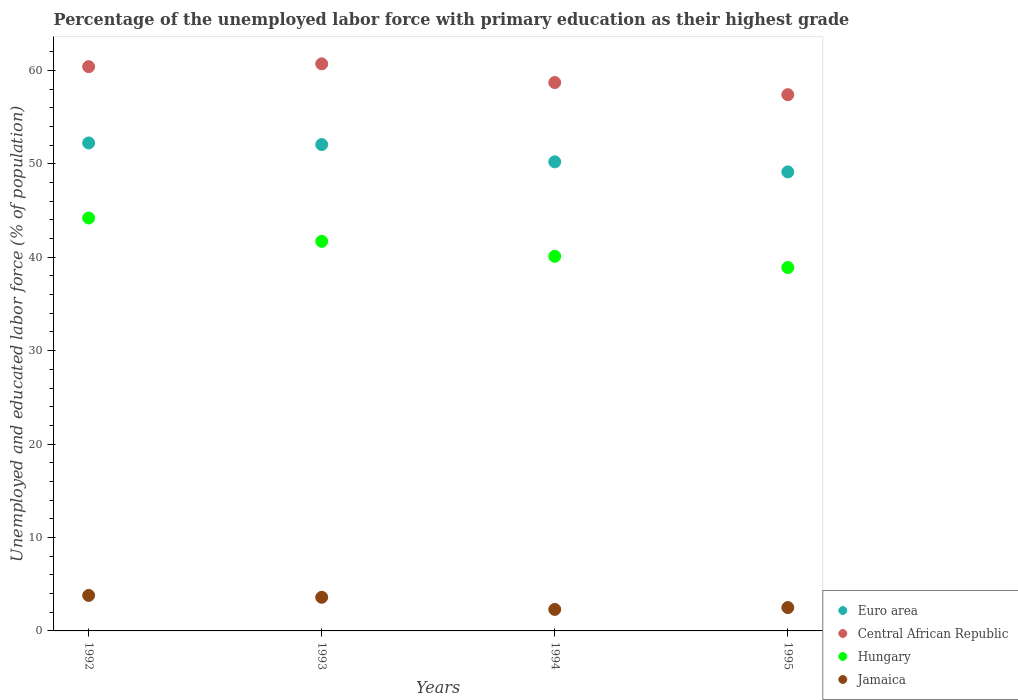What is the percentage of the unemployed labor force with primary education in Jamaica in 1994?
Give a very brief answer. 2.3. Across all years, what is the maximum percentage of the unemployed labor force with primary education in Euro area?
Provide a short and direct response. 52.23. Across all years, what is the minimum percentage of the unemployed labor force with primary education in Jamaica?
Make the answer very short. 2.3. What is the total percentage of the unemployed labor force with primary education in Jamaica in the graph?
Ensure brevity in your answer.  12.2. What is the difference between the percentage of the unemployed labor force with primary education in Hungary in 1992 and that in 1993?
Make the answer very short. 2.5. What is the difference between the percentage of the unemployed labor force with primary education in Hungary in 1993 and the percentage of the unemployed labor force with primary education in Euro area in 1995?
Ensure brevity in your answer.  -7.43. What is the average percentage of the unemployed labor force with primary education in Jamaica per year?
Keep it short and to the point. 3.05. In the year 1995, what is the difference between the percentage of the unemployed labor force with primary education in Euro area and percentage of the unemployed labor force with primary education in Central African Republic?
Give a very brief answer. -8.27. In how many years, is the percentage of the unemployed labor force with primary education in Hungary greater than 46 %?
Your answer should be compact. 0. What is the ratio of the percentage of the unemployed labor force with primary education in Euro area in 1992 to that in 1994?
Your answer should be very brief. 1.04. Is the percentage of the unemployed labor force with primary education in Jamaica in 1994 less than that in 1995?
Your answer should be very brief. Yes. Is the difference between the percentage of the unemployed labor force with primary education in Euro area in 1994 and 1995 greater than the difference between the percentage of the unemployed labor force with primary education in Central African Republic in 1994 and 1995?
Keep it short and to the point. No. What is the difference between the highest and the lowest percentage of the unemployed labor force with primary education in Euro area?
Offer a terse response. 3.1. In how many years, is the percentage of the unemployed labor force with primary education in Euro area greater than the average percentage of the unemployed labor force with primary education in Euro area taken over all years?
Your answer should be very brief. 2. Is it the case that in every year, the sum of the percentage of the unemployed labor force with primary education in Jamaica and percentage of the unemployed labor force with primary education in Euro area  is greater than the percentage of the unemployed labor force with primary education in Central African Republic?
Your answer should be compact. No. Does the percentage of the unemployed labor force with primary education in Hungary monotonically increase over the years?
Make the answer very short. No. How many dotlines are there?
Your answer should be very brief. 4. How many years are there in the graph?
Your response must be concise. 4. Are the values on the major ticks of Y-axis written in scientific E-notation?
Give a very brief answer. No. Does the graph contain any zero values?
Keep it short and to the point. No. How are the legend labels stacked?
Offer a terse response. Vertical. What is the title of the graph?
Your response must be concise. Percentage of the unemployed labor force with primary education as their highest grade. Does "Uruguay" appear as one of the legend labels in the graph?
Provide a succinct answer. No. What is the label or title of the X-axis?
Ensure brevity in your answer.  Years. What is the label or title of the Y-axis?
Offer a very short reply. Unemployed and educated labor force (% of population). What is the Unemployed and educated labor force (% of population) in Euro area in 1992?
Keep it short and to the point. 52.23. What is the Unemployed and educated labor force (% of population) in Central African Republic in 1992?
Keep it short and to the point. 60.4. What is the Unemployed and educated labor force (% of population) of Hungary in 1992?
Ensure brevity in your answer.  44.2. What is the Unemployed and educated labor force (% of population) of Jamaica in 1992?
Your answer should be very brief. 3.8. What is the Unemployed and educated labor force (% of population) of Euro area in 1993?
Provide a succinct answer. 52.06. What is the Unemployed and educated labor force (% of population) of Central African Republic in 1993?
Your response must be concise. 60.7. What is the Unemployed and educated labor force (% of population) of Hungary in 1993?
Offer a terse response. 41.7. What is the Unemployed and educated labor force (% of population) of Jamaica in 1993?
Your answer should be compact. 3.6. What is the Unemployed and educated labor force (% of population) in Euro area in 1994?
Ensure brevity in your answer.  50.21. What is the Unemployed and educated labor force (% of population) in Central African Republic in 1994?
Give a very brief answer. 58.7. What is the Unemployed and educated labor force (% of population) of Hungary in 1994?
Provide a short and direct response. 40.1. What is the Unemployed and educated labor force (% of population) in Jamaica in 1994?
Ensure brevity in your answer.  2.3. What is the Unemployed and educated labor force (% of population) of Euro area in 1995?
Offer a terse response. 49.13. What is the Unemployed and educated labor force (% of population) of Central African Republic in 1995?
Provide a succinct answer. 57.4. What is the Unemployed and educated labor force (% of population) in Hungary in 1995?
Keep it short and to the point. 38.9. What is the Unemployed and educated labor force (% of population) in Jamaica in 1995?
Give a very brief answer. 2.5. Across all years, what is the maximum Unemployed and educated labor force (% of population) of Euro area?
Ensure brevity in your answer.  52.23. Across all years, what is the maximum Unemployed and educated labor force (% of population) in Central African Republic?
Keep it short and to the point. 60.7. Across all years, what is the maximum Unemployed and educated labor force (% of population) of Hungary?
Provide a succinct answer. 44.2. Across all years, what is the maximum Unemployed and educated labor force (% of population) in Jamaica?
Offer a very short reply. 3.8. Across all years, what is the minimum Unemployed and educated labor force (% of population) of Euro area?
Offer a very short reply. 49.13. Across all years, what is the minimum Unemployed and educated labor force (% of population) of Central African Republic?
Offer a terse response. 57.4. Across all years, what is the minimum Unemployed and educated labor force (% of population) of Hungary?
Ensure brevity in your answer.  38.9. Across all years, what is the minimum Unemployed and educated labor force (% of population) of Jamaica?
Keep it short and to the point. 2.3. What is the total Unemployed and educated labor force (% of population) of Euro area in the graph?
Offer a very short reply. 203.64. What is the total Unemployed and educated labor force (% of population) of Central African Republic in the graph?
Your answer should be very brief. 237.2. What is the total Unemployed and educated labor force (% of population) of Hungary in the graph?
Keep it short and to the point. 164.9. What is the total Unemployed and educated labor force (% of population) of Jamaica in the graph?
Your answer should be very brief. 12.2. What is the difference between the Unemployed and educated labor force (% of population) of Euro area in 1992 and that in 1993?
Provide a short and direct response. 0.17. What is the difference between the Unemployed and educated labor force (% of population) of Central African Republic in 1992 and that in 1993?
Your response must be concise. -0.3. What is the difference between the Unemployed and educated labor force (% of population) of Jamaica in 1992 and that in 1993?
Make the answer very short. 0.2. What is the difference between the Unemployed and educated labor force (% of population) in Euro area in 1992 and that in 1994?
Provide a short and direct response. 2.02. What is the difference between the Unemployed and educated labor force (% of population) in Central African Republic in 1992 and that in 1994?
Your answer should be very brief. 1.7. What is the difference between the Unemployed and educated labor force (% of population) in Jamaica in 1992 and that in 1994?
Offer a terse response. 1.5. What is the difference between the Unemployed and educated labor force (% of population) in Euro area in 1992 and that in 1995?
Your answer should be compact. 3.1. What is the difference between the Unemployed and educated labor force (% of population) in Central African Republic in 1992 and that in 1995?
Your answer should be very brief. 3. What is the difference between the Unemployed and educated labor force (% of population) of Hungary in 1992 and that in 1995?
Provide a succinct answer. 5.3. What is the difference between the Unemployed and educated labor force (% of population) of Euro area in 1993 and that in 1994?
Your answer should be very brief. 1.85. What is the difference between the Unemployed and educated labor force (% of population) of Jamaica in 1993 and that in 1994?
Your response must be concise. 1.3. What is the difference between the Unemployed and educated labor force (% of population) of Euro area in 1993 and that in 1995?
Ensure brevity in your answer.  2.93. What is the difference between the Unemployed and educated labor force (% of population) of Hungary in 1993 and that in 1995?
Offer a very short reply. 2.8. What is the difference between the Unemployed and educated labor force (% of population) of Jamaica in 1993 and that in 1995?
Offer a terse response. 1.1. What is the difference between the Unemployed and educated labor force (% of population) of Euro area in 1994 and that in 1995?
Give a very brief answer. 1.08. What is the difference between the Unemployed and educated labor force (% of population) in Hungary in 1994 and that in 1995?
Give a very brief answer. 1.2. What is the difference between the Unemployed and educated labor force (% of population) of Euro area in 1992 and the Unemployed and educated labor force (% of population) of Central African Republic in 1993?
Your response must be concise. -8.47. What is the difference between the Unemployed and educated labor force (% of population) of Euro area in 1992 and the Unemployed and educated labor force (% of population) of Hungary in 1993?
Ensure brevity in your answer.  10.53. What is the difference between the Unemployed and educated labor force (% of population) of Euro area in 1992 and the Unemployed and educated labor force (% of population) of Jamaica in 1993?
Ensure brevity in your answer.  48.63. What is the difference between the Unemployed and educated labor force (% of population) of Central African Republic in 1992 and the Unemployed and educated labor force (% of population) of Hungary in 1993?
Keep it short and to the point. 18.7. What is the difference between the Unemployed and educated labor force (% of population) of Central African Republic in 1992 and the Unemployed and educated labor force (% of population) of Jamaica in 1993?
Provide a succinct answer. 56.8. What is the difference between the Unemployed and educated labor force (% of population) of Hungary in 1992 and the Unemployed and educated labor force (% of population) of Jamaica in 1993?
Your answer should be very brief. 40.6. What is the difference between the Unemployed and educated labor force (% of population) of Euro area in 1992 and the Unemployed and educated labor force (% of population) of Central African Republic in 1994?
Offer a terse response. -6.47. What is the difference between the Unemployed and educated labor force (% of population) in Euro area in 1992 and the Unemployed and educated labor force (% of population) in Hungary in 1994?
Offer a very short reply. 12.13. What is the difference between the Unemployed and educated labor force (% of population) of Euro area in 1992 and the Unemployed and educated labor force (% of population) of Jamaica in 1994?
Your response must be concise. 49.93. What is the difference between the Unemployed and educated labor force (% of population) of Central African Republic in 1992 and the Unemployed and educated labor force (% of population) of Hungary in 1994?
Ensure brevity in your answer.  20.3. What is the difference between the Unemployed and educated labor force (% of population) of Central African Republic in 1992 and the Unemployed and educated labor force (% of population) of Jamaica in 1994?
Make the answer very short. 58.1. What is the difference between the Unemployed and educated labor force (% of population) in Hungary in 1992 and the Unemployed and educated labor force (% of population) in Jamaica in 1994?
Provide a succinct answer. 41.9. What is the difference between the Unemployed and educated labor force (% of population) in Euro area in 1992 and the Unemployed and educated labor force (% of population) in Central African Republic in 1995?
Your response must be concise. -5.17. What is the difference between the Unemployed and educated labor force (% of population) of Euro area in 1992 and the Unemployed and educated labor force (% of population) of Hungary in 1995?
Give a very brief answer. 13.33. What is the difference between the Unemployed and educated labor force (% of population) of Euro area in 1992 and the Unemployed and educated labor force (% of population) of Jamaica in 1995?
Provide a succinct answer. 49.73. What is the difference between the Unemployed and educated labor force (% of population) in Central African Republic in 1992 and the Unemployed and educated labor force (% of population) in Jamaica in 1995?
Offer a very short reply. 57.9. What is the difference between the Unemployed and educated labor force (% of population) in Hungary in 1992 and the Unemployed and educated labor force (% of population) in Jamaica in 1995?
Ensure brevity in your answer.  41.7. What is the difference between the Unemployed and educated labor force (% of population) of Euro area in 1993 and the Unemployed and educated labor force (% of population) of Central African Republic in 1994?
Your response must be concise. -6.64. What is the difference between the Unemployed and educated labor force (% of population) in Euro area in 1993 and the Unemployed and educated labor force (% of population) in Hungary in 1994?
Offer a very short reply. 11.96. What is the difference between the Unemployed and educated labor force (% of population) of Euro area in 1993 and the Unemployed and educated labor force (% of population) of Jamaica in 1994?
Ensure brevity in your answer.  49.76. What is the difference between the Unemployed and educated labor force (% of population) of Central African Republic in 1993 and the Unemployed and educated labor force (% of population) of Hungary in 1994?
Keep it short and to the point. 20.6. What is the difference between the Unemployed and educated labor force (% of population) of Central African Republic in 1993 and the Unemployed and educated labor force (% of population) of Jamaica in 1994?
Offer a terse response. 58.4. What is the difference between the Unemployed and educated labor force (% of population) in Hungary in 1993 and the Unemployed and educated labor force (% of population) in Jamaica in 1994?
Keep it short and to the point. 39.4. What is the difference between the Unemployed and educated labor force (% of population) in Euro area in 1993 and the Unemployed and educated labor force (% of population) in Central African Republic in 1995?
Offer a terse response. -5.34. What is the difference between the Unemployed and educated labor force (% of population) in Euro area in 1993 and the Unemployed and educated labor force (% of population) in Hungary in 1995?
Offer a very short reply. 13.16. What is the difference between the Unemployed and educated labor force (% of population) in Euro area in 1993 and the Unemployed and educated labor force (% of population) in Jamaica in 1995?
Provide a short and direct response. 49.56. What is the difference between the Unemployed and educated labor force (% of population) in Central African Republic in 1993 and the Unemployed and educated labor force (% of population) in Hungary in 1995?
Provide a short and direct response. 21.8. What is the difference between the Unemployed and educated labor force (% of population) in Central African Republic in 1993 and the Unemployed and educated labor force (% of population) in Jamaica in 1995?
Your answer should be compact. 58.2. What is the difference between the Unemployed and educated labor force (% of population) in Hungary in 1993 and the Unemployed and educated labor force (% of population) in Jamaica in 1995?
Your answer should be compact. 39.2. What is the difference between the Unemployed and educated labor force (% of population) of Euro area in 1994 and the Unemployed and educated labor force (% of population) of Central African Republic in 1995?
Make the answer very short. -7.19. What is the difference between the Unemployed and educated labor force (% of population) in Euro area in 1994 and the Unemployed and educated labor force (% of population) in Hungary in 1995?
Provide a short and direct response. 11.31. What is the difference between the Unemployed and educated labor force (% of population) of Euro area in 1994 and the Unemployed and educated labor force (% of population) of Jamaica in 1995?
Provide a succinct answer. 47.71. What is the difference between the Unemployed and educated labor force (% of population) of Central African Republic in 1994 and the Unemployed and educated labor force (% of population) of Hungary in 1995?
Make the answer very short. 19.8. What is the difference between the Unemployed and educated labor force (% of population) of Central African Republic in 1994 and the Unemployed and educated labor force (% of population) of Jamaica in 1995?
Offer a very short reply. 56.2. What is the difference between the Unemployed and educated labor force (% of population) of Hungary in 1994 and the Unemployed and educated labor force (% of population) of Jamaica in 1995?
Provide a succinct answer. 37.6. What is the average Unemployed and educated labor force (% of population) of Euro area per year?
Give a very brief answer. 50.91. What is the average Unemployed and educated labor force (% of population) of Central African Republic per year?
Your answer should be very brief. 59.3. What is the average Unemployed and educated labor force (% of population) in Hungary per year?
Make the answer very short. 41.23. What is the average Unemployed and educated labor force (% of population) in Jamaica per year?
Make the answer very short. 3.05. In the year 1992, what is the difference between the Unemployed and educated labor force (% of population) of Euro area and Unemployed and educated labor force (% of population) of Central African Republic?
Your answer should be very brief. -8.17. In the year 1992, what is the difference between the Unemployed and educated labor force (% of population) in Euro area and Unemployed and educated labor force (% of population) in Hungary?
Your answer should be compact. 8.03. In the year 1992, what is the difference between the Unemployed and educated labor force (% of population) of Euro area and Unemployed and educated labor force (% of population) of Jamaica?
Provide a succinct answer. 48.43. In the year 1992, what is the difference between the Unemployed and educated labor force (% of population) in Central African Republic and Unemployed and educated labor force (% of population) in Jamaica?
Make the answer very short. 56.6. In the year 1992, what is the difference between the Unemployed and educated labor force (% of population) of Hungary and Unemployed and educated labor force (% of population) of Jamaica?
Keep it short and to the point. 40.4. In the year 1993, what is the difference between the Unemployed and educated labor force (% of population) of Euro area and Unemployed and educated labor force (% of population) of Central African Republic?
Your answer should be compact. -8.64. In the year 1993, what is the difference between the Unemployed and educated labor force (% of population) in Euro area and Unemployed and educated labor force (% of population) in Hungary?
Provide a succinct answer. 10.36. In the year 1993, what is the difference between the Unemployed and educated labor force (% of population) of Euro area and Unemployed and educated labor force (% of population) of Jamaica?
Ensure brevity in your answer.  48.46. In the year 1993, what is the difference between the Unemployed and educated labor force (% of population) in Central African Republic and Unemployed and educated labor force (% of population) in Jamaica?
Your answer should be compact. 57.1. In the year 1993, what is the difference between the Unemployed and educated labor force (% of population) in Hungary and Unemployed and educated labor force (% of population) in Jamaica?
Your answer should be compact. 38.1. In the year 1994, what is the difference between the Unemployed and educated labor force (% of population) in Euro area and Unemployed and educated labor force (% of population) in Central African Republic?
Your response must be concise. -8.49. In the year 1994, what is the difference between the Unemployed and educated labor force (% of population) of Euro area and Unemployed and educated labor force (% of population) of Hungary?
Ensure brevity in your answer.  10.11. In the year 1994, what is the difference between the Unemployed and educated labor force (% of population) in Euro area and Unemployed and educated labor force (% of population) in Jamaica?
Your answer should be very brief. 47.91. In the year 1994, what is the difference between the Unemployed and educated labor force (% of population) in Central African Republic and Unemployed and educated labor force (% of population) in Jamaica?
Your answer should be compact. 56.4. In the year 1994, what is the difference between the Unemployed and educated labor force (% of population) of Hungary and Unemployed and educated labor force (% of population) of Jamaica?
Keep it short and to the point. 37.8. In the year 1995, what is the difference between the Unemployed and educated labor force (% of population) in Euro area and Unemployed and educated labor force (% of population) in Central African Republic?
Offer a terse response. -8.27. In the year 1995, what is the difference between the Unemployed and educated labor force (% of population) of Euro area and Unemployed and educated labor force (% of population) of Hungary?
Give a very brief answer. 10.23. In the year 1995, what is the difference between the Unemployed and educated labor force (% of population) of Euro area and Unemployed and educated labor force (% of population) of Jamaica?
Offer a very short reply. 46.63. In the year 1995, what is the difference between the Unemployed and educated labor force (% of population) of Central African Republic and Unemployed and educated labor force (% of population) of Jamaica?
Your answer should be compact. 54.9. In the year 1995, what is the difference between the Unemployed and educated labor force (% of population) in Hungary and Unemployed and educated labor force (% of population) in Jamaica?
Keep it short and to the point. 36.4. What is the ratio of the Unemployed and educated labor force (% of population) in Euro area in 1992 to that in 1993?
Provide a succinct answer. 1. What is the ratio of the Unemployed and educated labor force (% of population) in Hungary in 1992 to that in 1993?
Your answer should be compact. 1.06. What is the ratio of the Unemployed and educated labor force (% of population) of Jamaica in 1992 to that in 1993?
Ensure brevity in your answer.  1.06. What is the ratio of the Unemployed and educated labor force (% of population) in Euro area in 1992 to that in 1994?
Ensure brevity in your answer.  1.04. What is the ratio of the Unemployed and educated labor force (% of population) in Central African Republic in 1992 to that in 1994?
Your response must be concise. 1.03. What is the ratio of the Unemployed and educated labor force (% of population) in Hungary in 1992 to that in 1994?
Ensure brevity in your answer.  1.1. What is the ratio of the Unemployed and educated labor force (% of population) of Jamaica in 1992 to that in 1994?
Ensure brevity in your answer.  1.65. What is the ratio of the Unemployed and educated labor force (% of population) in Euro area in 1992 to that in 1995?
Offer a terse response. 1.06. What is the ratio of the Unemployed and educated labor force (% of population) of Central African Republic in 1992 to that in 1995?
Your answer should be very brief. 1.05. What is the ratio of the Unemployed and educated labor force (% of population) in Hungary in 1992 to that in 1995?
Your answer should be very brief. 1.14. What is the ratio of the Unemployed and educated labor force (% of population) of Jamaica in 1992 to that in 1995?
Offer a terse response. 1.52. What is the ratio of the Unemployed and educated labor force (% of population) in Euro area in 1993 to that in 1994?
Your response must be concise. 1.04. What is the ratio of the Unemployed and educated labor force (% of population) in Central African Republic in 1993 to that in 1994?
Make the answer very short. 1.03. What is the ratio of the Unemployed and educated labor force (% of population) of Hungary in 1993 to that in 1994?
Provide a succinct answer. 1.04. What is the ratio of the Unemployed and educated labor force (% of population) in Jamaica in 1993 to that in 1994?
Offer a very short reply. 1.57. What is the ratio of the Unemployed and educated labor force (% of population) in Euro area in 1993 to that in 1995?
Provide a succinct answer. 1.06. What is the ratio of the Unemployed and educated labor force (% of population) of Central African Republic in 1993 to that in 1995?
Make the answer very short. 1.06. What is the ratio of the Unemployed and educated labor force (% of population) of Hungary in 1993 to that in 1995?
Your answer should be compact. 1.07. What is the ratio of the Unemployed and educated labor force (% of population) in Jamaica in 1993 to that in 1995?
Keep it short and to the point. 1.44. What is the ratio of the Unemployed and educated labor force (% of population) of Euro area in 1994 to that in 1995?
Your answer should be compact. 1.02. What is the ratio of the Unemployed and educated labor force (% of population) in Central African Republic in 1994 to that in 1995?
Give a very brief answer. 1.02. What is the ratio of the Unemployed and educated labor force (% of population) in Hungary in 1994 to that in 1995?
Offer a very short reply. 1.03. What is the difference between the highest and the second highest Unemployed and educated labor force (% of population) of Euro area?
Provide a succinct answer. 0.17. What is the difference between the highest and the second highest Unemployed and educated labor force (% of population) in Central African Republic?
Offer a terse response. 0.3. What is the difference between the highest and the lowest Unemployed and educated labor force (% of population) in Euro area?
Offer a very short reply. 3.1. What is the difference between the highest and the lowest Unemployed and educated labor force (% of population) in Central African Republic?
Make the answer very short. 3.3. What is the difference between the highest and the lowest Unemployed and educated labor force (% of population) of Hungary?
Make the answer very short. 5.3. 